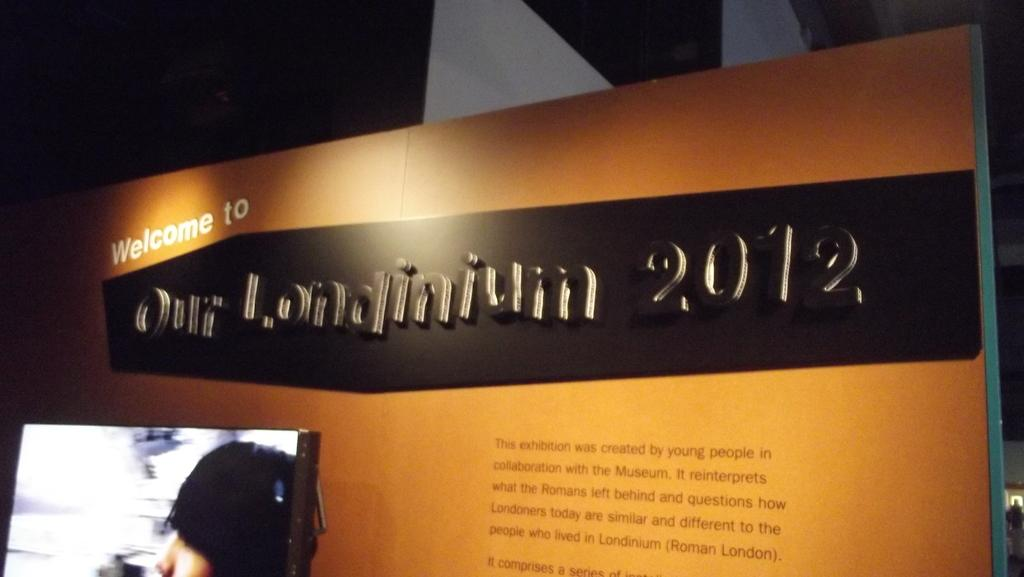What electronic device is visible in the image? There is a monitor in the image. What is located behind the monitor? There is a board behind the monitor. Can you describe the overall lighting in the image? The background of the image is dark. How many markets are visible in the image? There are no markets present in the image; it features a monitor and a board. What type of mass is being performed in the image? There is no mass or religious ceremony depicted in the image; it focuses on a monitor and a board. 